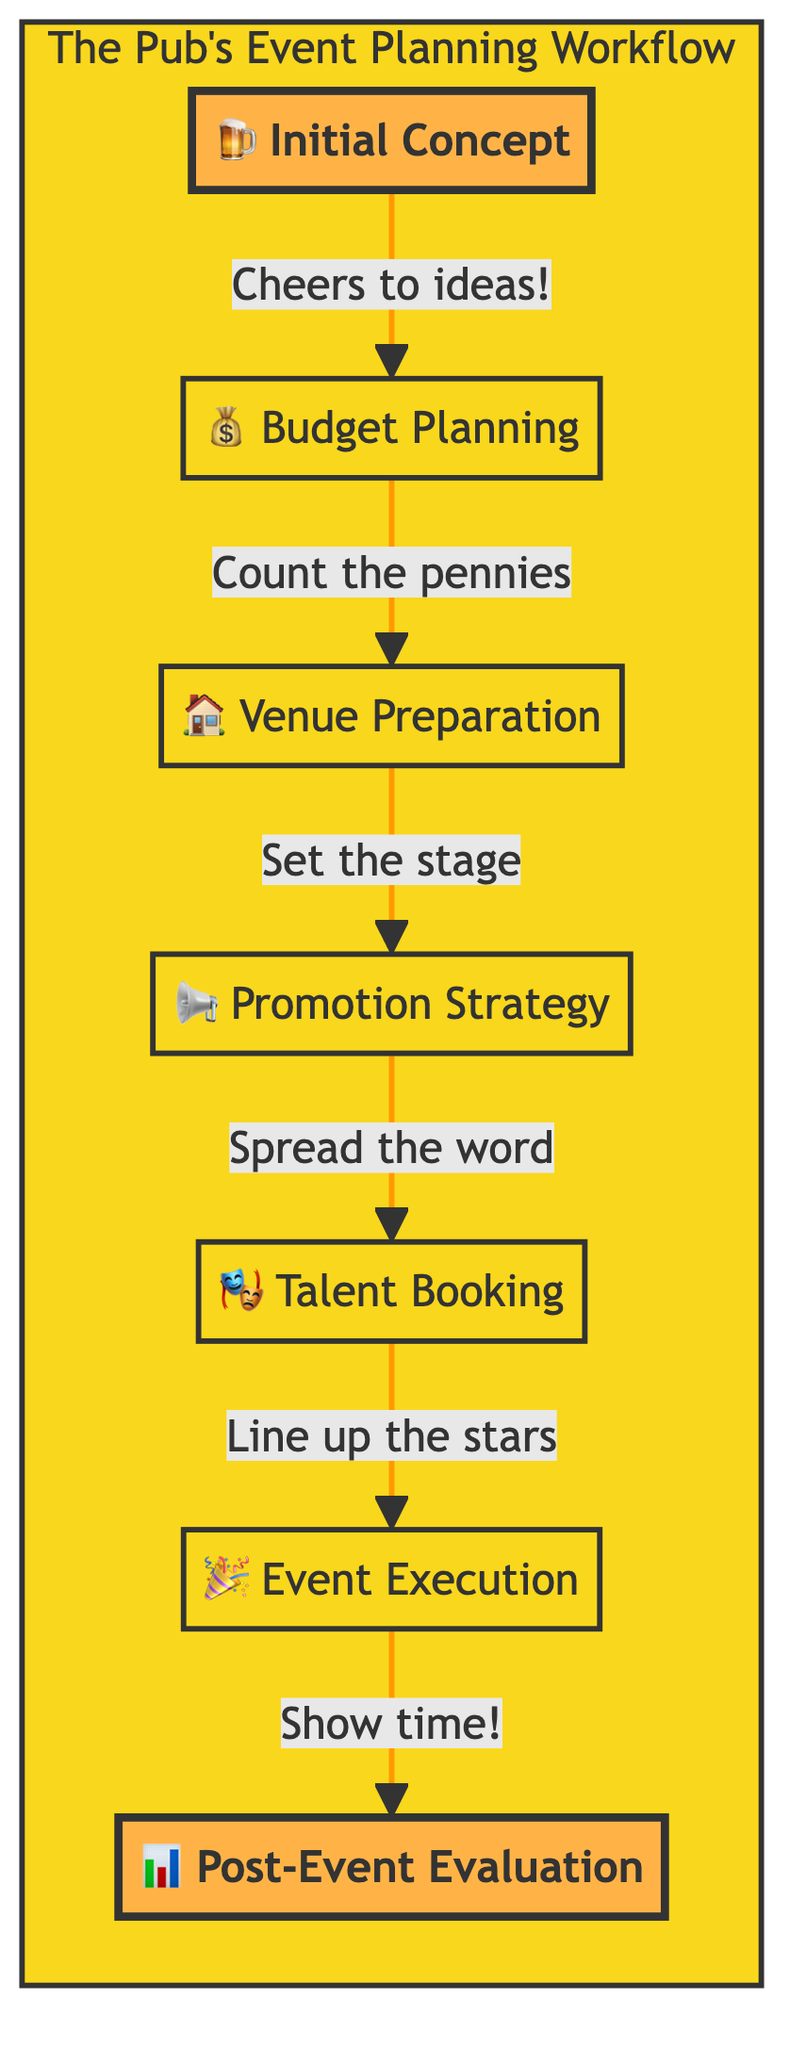What is the first step in the event planning workflow? The first step outlined in the flow chart is "Initial Concept," which is where ideas for events are brainstormed.
Answer: Initial Concept How many main steps are there in the workflow? By counting all individual nodes in the diagram, we find there are seven distinct steps from "Initial Concept" to "Post-Event Evaluation."
Answer: 7 What follows after "Budget Planning"? According to the flow chart, "Venue Preparation" is the next step that comes immediately after "Budget Planning."
Answer: Venue Preparation Which step involves marketing? The step labeled "Promotion Strategy" specifically deals with creating a marketing plan to promote the event.
Answer: Promotion Strategy What is the last step in the event planning process? The final step in the workflow is "Post-Event Evaluation," which assesses the event's success and gathers feedback.
Answer: Post-Event Evaluation What is the relationship between "Talent Booking" and "Event Execution"? "Talent Booking" precedes "Event Execution," meaning that booking the talent is a necessary step before executing the event.
Answer: Precedes How does the flow of the diagram start and end? The flow starts with "Initial Concept" and moves through several steps, culminating at "Post-Event Evaluation," which marks the conclusion of the planning process.
Answer: Starts with Initial Concept, ends at Post-Event Evaluation What task is highlighted in the diagram? The tasks "Initial Concept" and "Post-Event Evaluation" are highlighted to signify their importance in the planning workflow.
Answer: Initial Concept and Post-Event Evaluation 